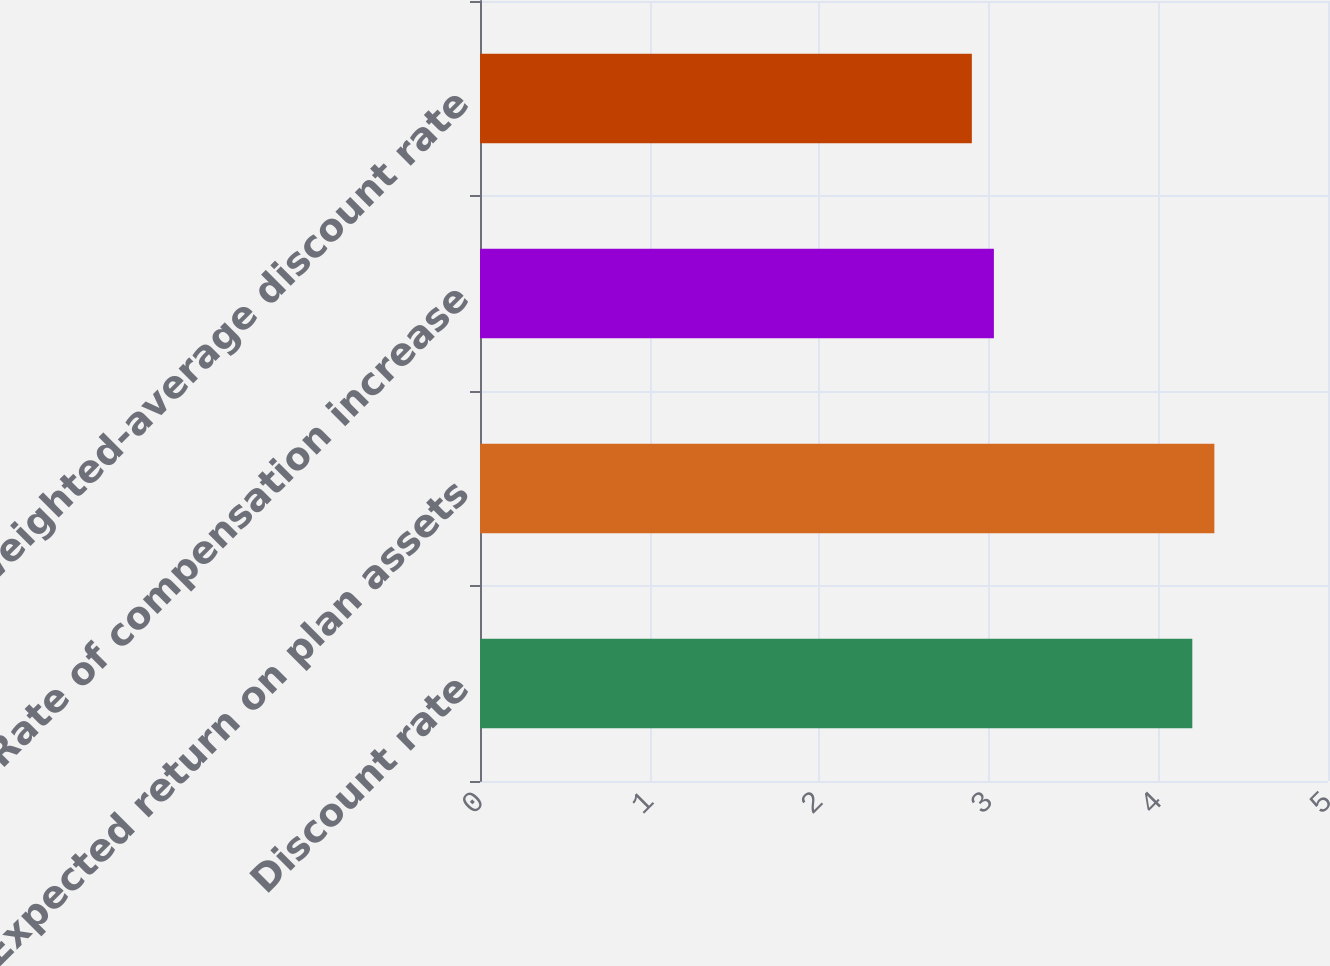Convert chart. <chart><loc_0><loc_0><loc_500><loc_500><bar_chart><fcel>Discount rate<fcel>Expected return on plan assets<fcel>Rate of compensation increase<fcel>Weighted-average discount rate<nl><fcel>4.2<fcel>4.33<fcel>3.03<fcel>2.9<nl></chart> 